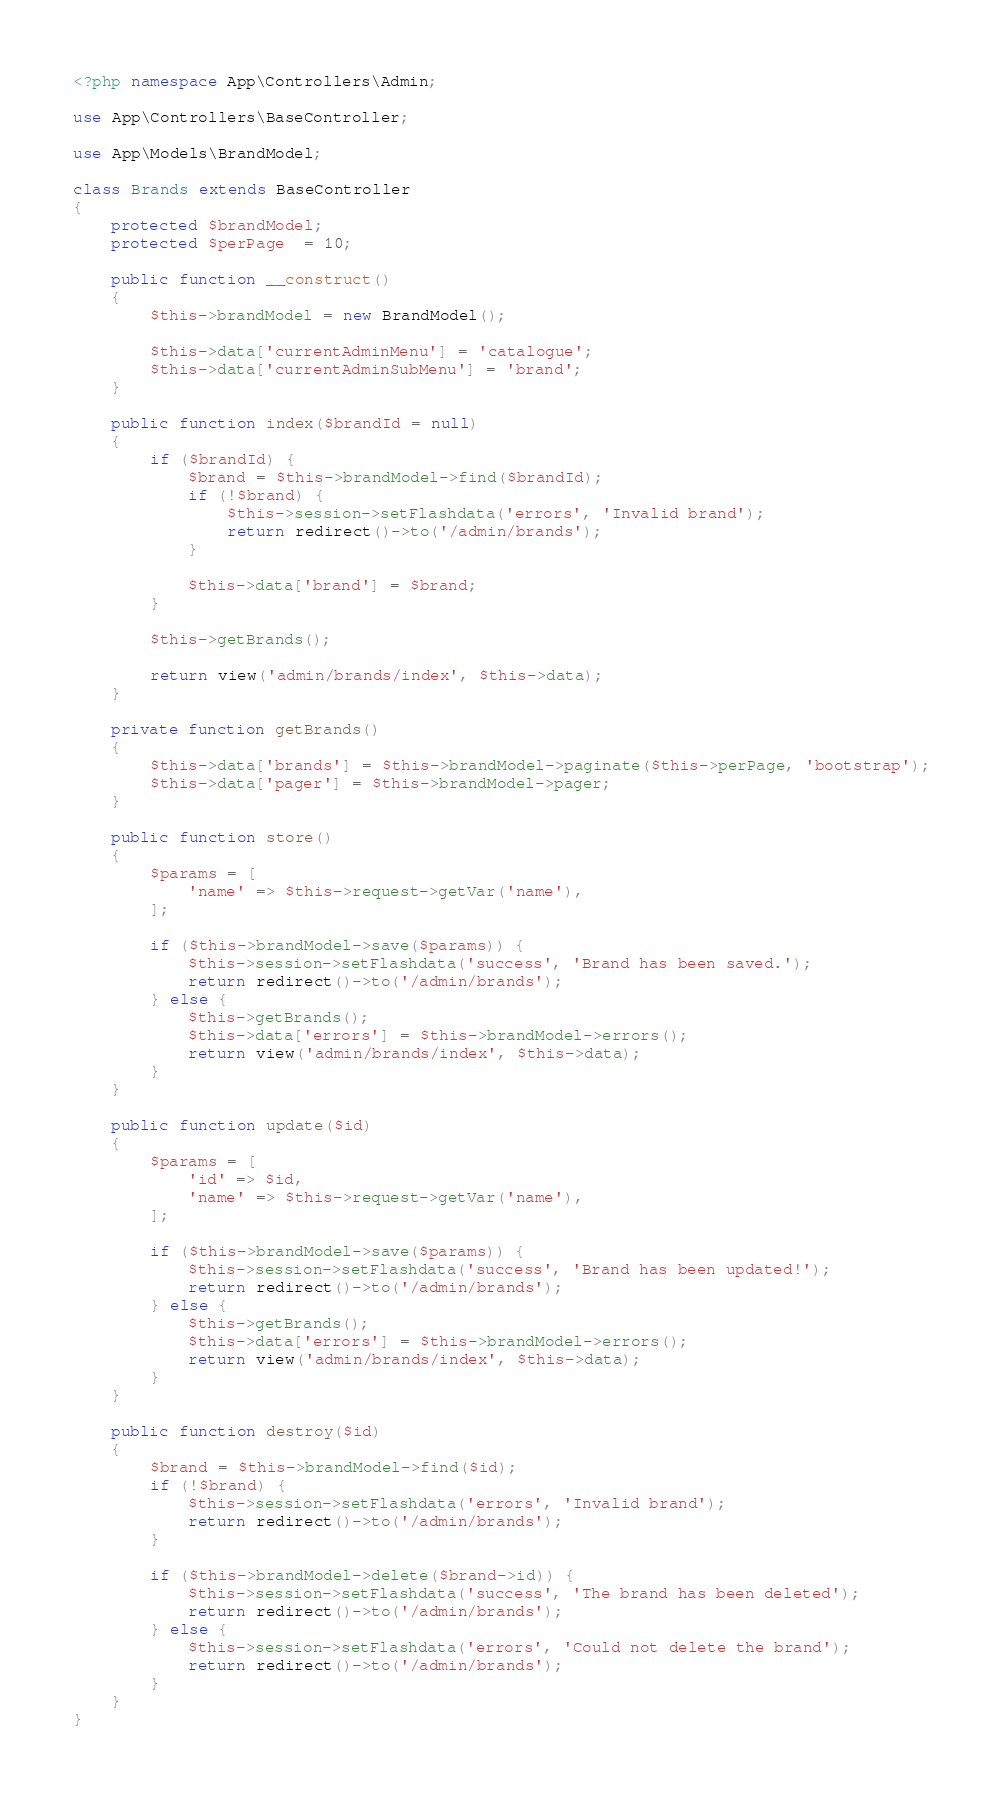Convert code to text. <code><loc_0><loc_0><loc_500><loc_500><_PHP_><?php namespace App\Controllers\Admin;

use App\Controllers\BaseController;

use App\Models\BrandModel;

class Brands extends BaseController
{
    protected $brandModel;
    protected $perPage  = 10;

    public function __construct()
    {
        $this->brandModel = new BrandModel();

        $this->data['currentAdminMenu'] = 'catalogue';
        $this->data['currentAdminSubMenu'] = 'brand';
    }

    public function index($brandId = null)
    {
        if ($brandId) {
            $brand = $this->brandModel->find($brandId);
            if (!$brand) {
                $this->session->setFlashdata('errors', 'Invalid brand');
                return redirect()->to('/admin/brands');
            }

            $this->data['brand'] = $brand;
        }

        $this->getBrands();

        return view('admin/brands/index', $this->data);
    }

    private function getBrands()
    {
        $this->data['brands'] = $this->brandModel->paginate($this->perPage, 'bootstrap');
        $this->data['pager'] = $this->brandModel->pager;
    }

    public function store()
    {
        $params = [
            'name' => $this->request->getVar('name'),
        ];

        if ($this->brandModel->save($params)) {
            $this->session->setFlashdata('success', 'Brand has been saved.');
            return redirect()->to('/admin/brands');
        } else {
            $this->getBrands();
            $this->data['errors'] = $this->brandModel->errors();
            return view('admin/brands/index', $this->data);
        }
    }

    public function update($id)
    {
        $params = [
			'id' => $id,
            'name' => $this->request->getVar('name'),
        ];

		if ($this->brandModel->save($params)) {
			$this->session->setFlashdata('success', 'Brand has been updated!');
			return redirect()->to('/admin/brands');
		} else {
			$this->getBrands();
			$this->data['errors'] = $this->brandModel->errors();
			return view('admin/brands/index', $this->data);
		}
    }

    public function destroy($id)
    {
        $brand = $this->brandModel->find($id);
		if (!$brand) {
			$this->session->setFlashdata('errors', 'Invalid brand');
			return redirect()->to('/admin/brands');
		}

		if ($this->brandModel->delete($brand->id)) {
			$this->session->setFlashdata('success', 'The brand has been deleted');
			return redirect()->to('/admin/brands');
		} else {
			$this->session->setFlashdata('errors', 'Could not delete the brand');
			return redirect()->to('/admin/brands');
		}
    }
}</code> 